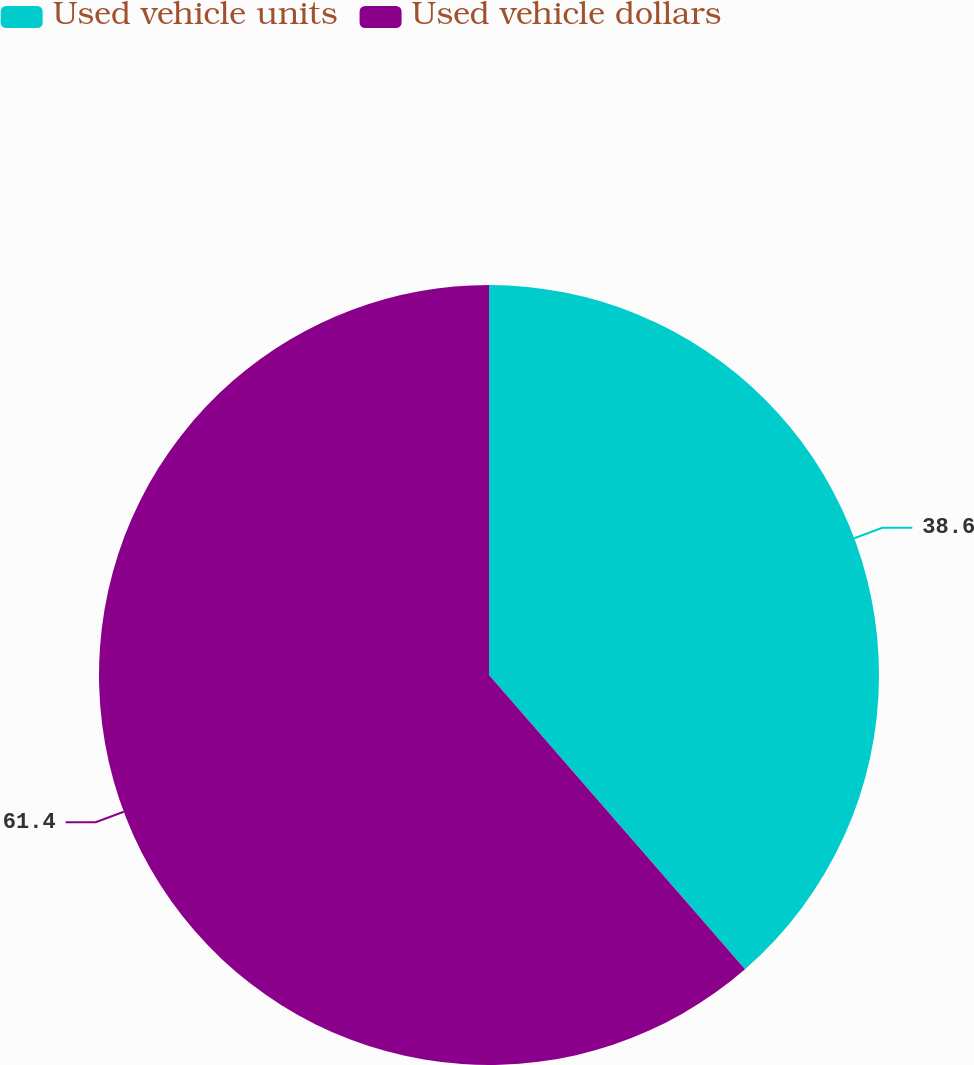Convert chart to OTSL. <chart><loc_0><loc_0><loc_500><loc_500><pie_chart><fcel>Used vehicle units<fcel>Used vehicle dollars<nl><fcel>38.6%<fcel>61.4%<nl></chart> 